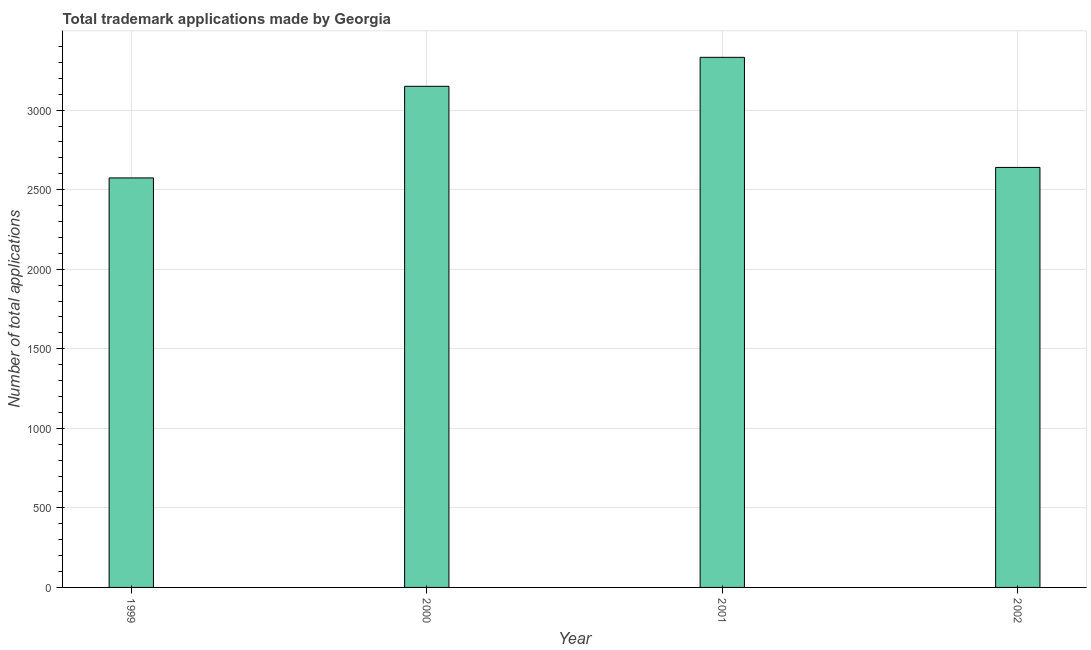Does the graph contain grids?
Offer a very short reply. Yes. What is the title of the graph?
Your answer should be very brief. Total trademark applications made by Georgia. What is the label or title of the Y-axis?
Offer a terse response. Number of total applications. What is the number of trademark applications in 2000?
Give a very brief answer. 3150. Across all years, what is the maximum number of trademark applications?
Offer a very short reply. 3332. Across all years, what is the minimum number of trademark applications?
Provide a short and direct response. 2574. What is the sum of the number of trademark applications?
Your answer should be very brief. 1.17e+04. What is the difference between the number of trademark applications in 1999 and 2001?
Your response must be concise. -758. What is the average number of trademark applications per year?
Your answer should be very brief. 2924. What is the median number of trademark applications?
Provide a short and direct response. 2895. In how many years, is the number of trademark applications greater than 500 ?
Your response must be concise. 4. What is the ratio of the number of trademark applications in 1999 to that in 2001?
Your answer should be compact. 0.77. Is the number of trademark applications in 1999 less than that in 2000?
Offer a very short reply. Yes. What is the difference between the highest and the second highest number of trademark applications?
Your answer should be very brief. 182. What is the difference between the highest and the lowest number of trademark applications?
Provide a short and direct response. 758. In how many years, is the number of trademark applications greater than the average number of trademark applications taken over all years?
Provide a succinct answer. 2. How many bars are there?
Make the answer very short. 4. How many years are there in the graph?
Offer a terse response. 4. What is the difference between two consecutive major ticks on the Y-axis?
Provide a short and direct response. 500. What is the Number of total applications of 1999?
Your answer should be compact. 2574. What is the Number of total applications in 2000?
Your answer should be compact. 3150. What is the Number of total applications of 2001?
Keep it short and to the point. 3332. What is the Number of total applications of 2002?
Provide a short and direct response. 2640. What is the difference between the Number of total applications in 1999 and 2000?
Offer a terse response. -576. What is the difference between the Number of total applications in 1999 and 2001?
Provide a short and direct response. -758. What is the difference between the Number of total applications in 1999 and 2002?
Provide a succinct answer. -66. What is the difference between the Number of total applications in 2000 and 2001?
Your answer should be compact. -182. What is the difference between the Number of total applications in 2000 and 2002?
Your answer should be compact. 510. What is the difference between the Number of total applications in 2001 and 2002?
Offer a very short reply. 692. What is the ratio of the Number of total applications in 1999 to that in 2000?
Make the answer very short. 0.82. What is the ratio of the Number of total applications in 1999 to that in 2001?
Provide a short and direct response. 0.77. What is the ratio of the Number of total applications in 2000 to that in 2001?
Ensure brevity in your answer.  0.94. What is the ratio of the Number of total applications in 2000 to that in 2002?
Your response must be concise. 1.19. What is the ratio of the Number of total applications in 2001 to that in 2002?
Offer a very short reply. 1.26. 